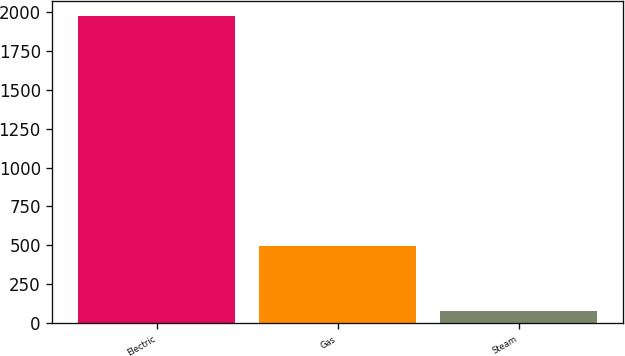Convert chart. <chart><loc_0><loc_0><loc_500><loc_500><bar_chart><fcel>Electric<fcel>Gas<fcel>Steam<nl><fcel>1974<fcel>495<fcel>80<nl></chart> 